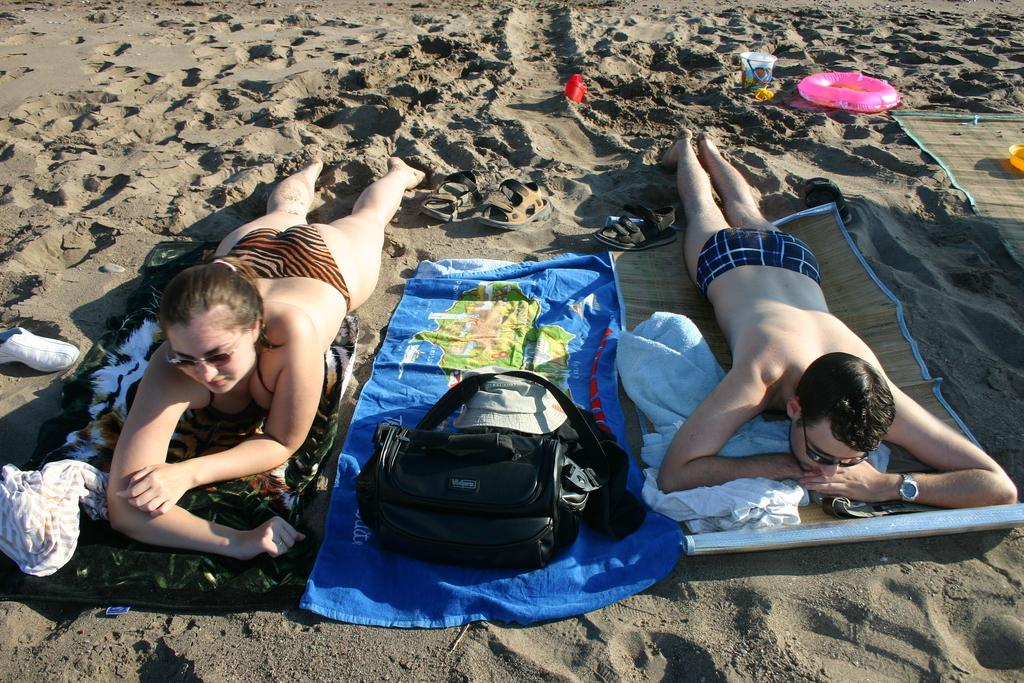What are the two people doing in the image? The two people are lying on the beach sand in the image. What are the people lying on? The people are lying on mats. What items can be seen in the image besides the people and mats? There are bags, shoes, clothes, and other objects in the image. How many rabbits can be seen hopping on the railway in the image? There are no rabbits or railway present in the image; it features two people lying on the beach sand. What level of experience do the people have in beach activities in the image? The image does not provide information about the people's experience in beach activities, so it cannot be determined. 